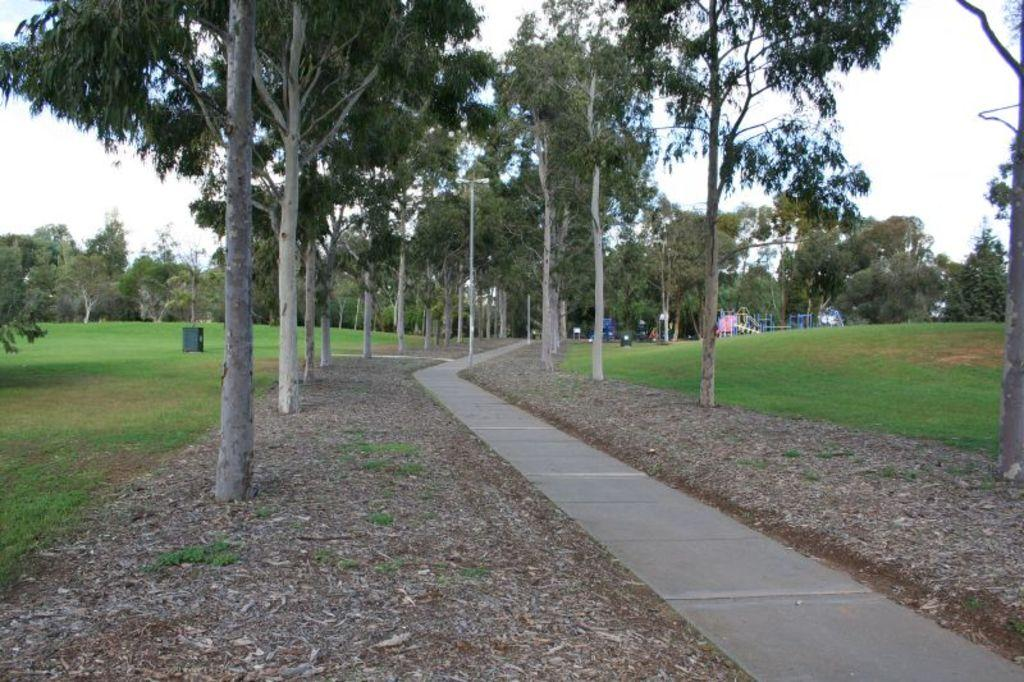What is the main feature in the center of the image? There is a road in the center of the image. What can be seen on either side of the road? There are trees and grass on either side of the road. What is visible in the background of the image? The sky is visible in the background of the image. How many cacti are present on the road in the image? There are no cacti present in the image; the image features trees and grass on either side of the road. 